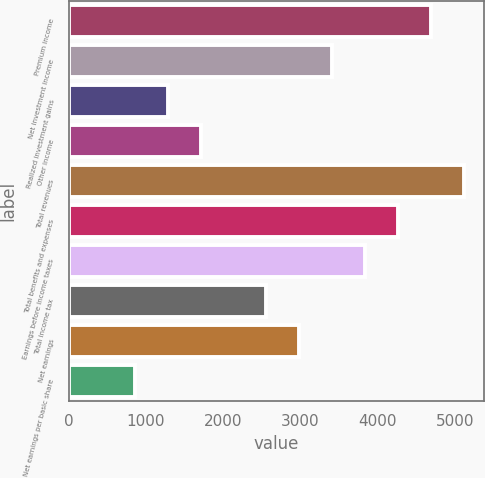<chart> <loc_0><loc_0><loc_500><loc_500><bar_chart><fcel>Premium income<fcel>Net investment income<fcel>Realized investment gains<fcel>Other income<fcel>Total revenues<fcel>Total benefits and expenses<fcel>Earnings before income taxes<fcel>Total income tax<fcel>Net earnings<fcel>Net earnings per basic share<nl><fcel>4693.72<fcel>3413.68<fcel>1280.28<fcel>1706.96<fcel>5120.4<fcel>4267.04<fcel>3840.36<fcel>2560.32<fcel>2987<fcel>853.6<nl></chart> 